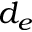<formula> <loc_0><loc_0><loc_500><loc_500>d _ { e }</formula> 